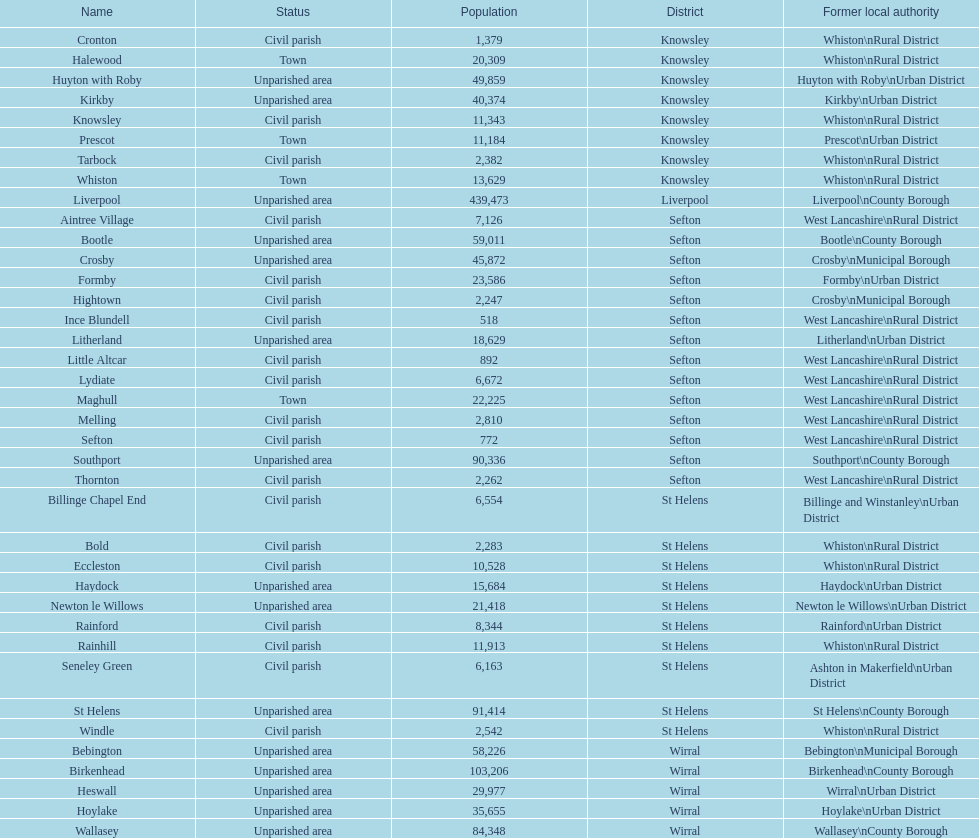Which area has the least number of residents? Ince Blundell. 